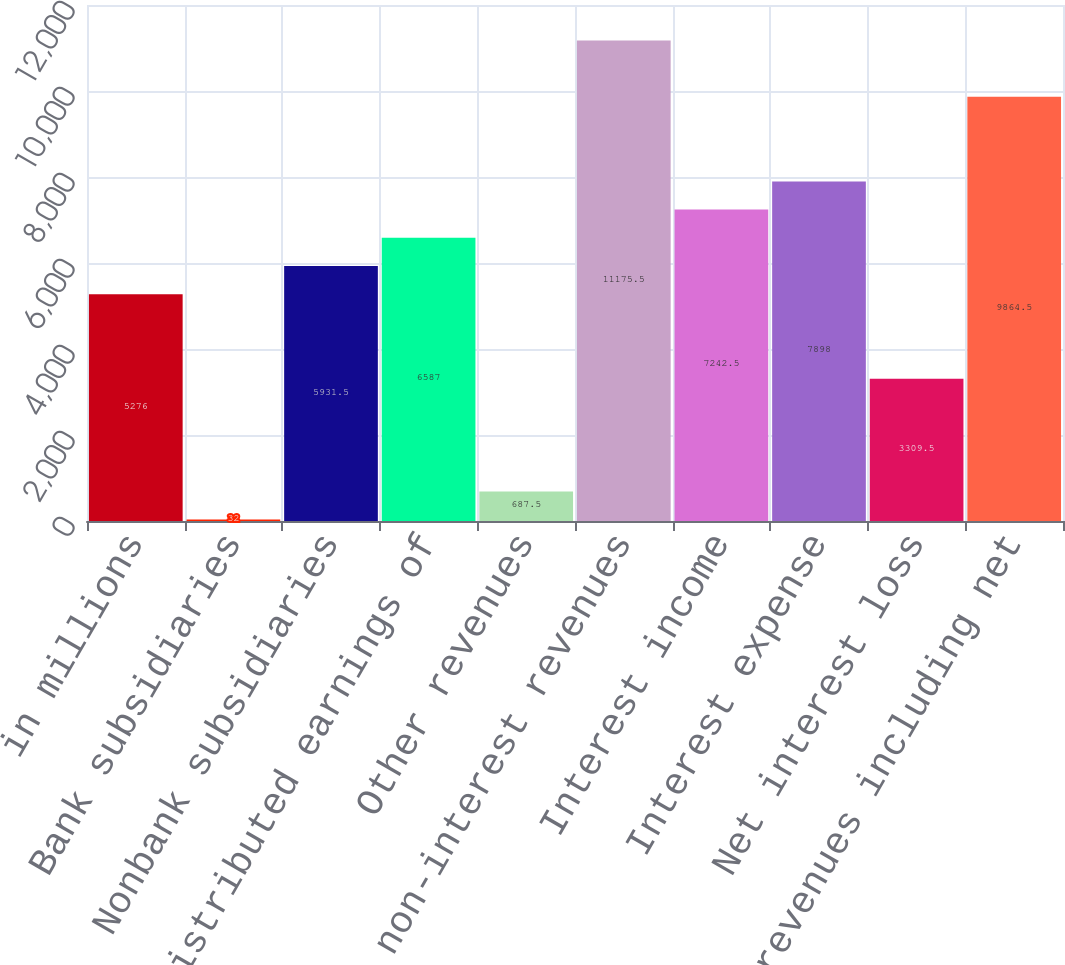Convert chart to OTSL. <chart><loc_0><loc_0><loc_500><loc_500><bar_chart><fcel>in millions<fcel>Bank subsidiaries<fcel>Nonbank subsidiaries<fcel>Undistributed earnings of<fcel>Other revenues<fcel>Total non-interest revenues<fcel>Interest income<fcel>Interest expense<fcel>Net interest loss<fcel>Net revenues including net<nl><fcel>5276<fcel>32<fcel>5931.5<fcel>6587<fcel>687.5<fcel>11175.5<fcel>7242.5<fcel>7898<fcel>3309.5<fcel>9864.5<nl></chart> 